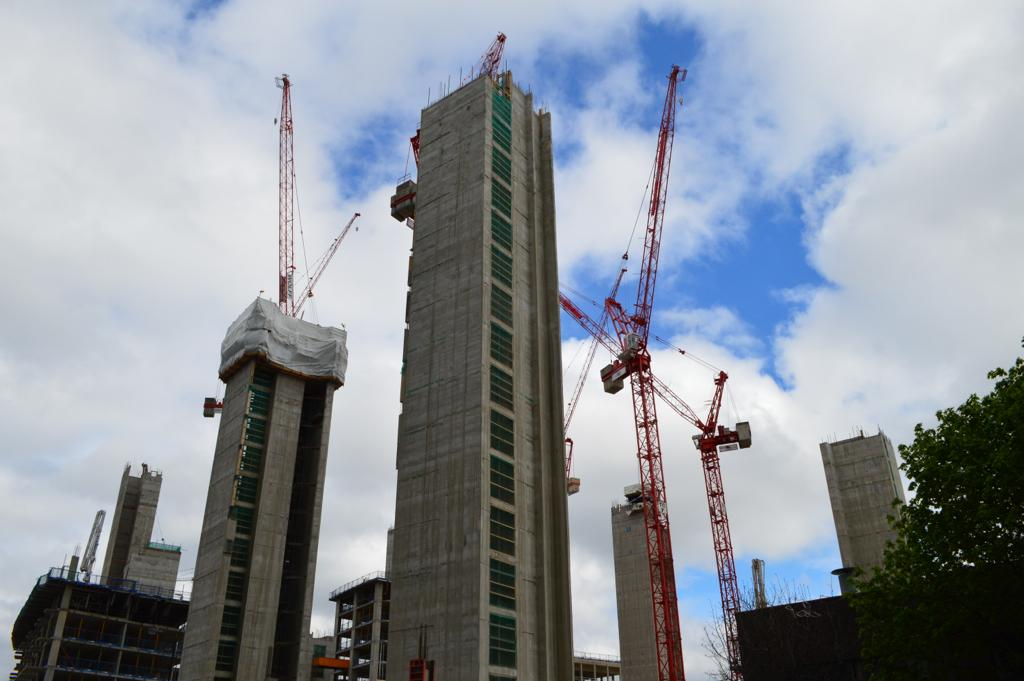What type of natural element can be seen in the image? There is a tree in the image. What type of structures are present in the image? There are buildings in the image, and they are ash in color. What type of machinery is present in the image? There are cranes in the image, and they are orange in color. What can be seen in the background of the image? The sky is visible in the background of the image. How many wings does the tree have in the image? Trees do not have wings; they are plants with branches and leaves. What trick can be performed with the cranes in the image? The image does not depict any tricks being performed with the cranes; they are simply present as machinery. 